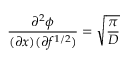<formula> <loc_0><loc_0><loc_500><loc_500>\frac { \partial ^ { 2 } { \phi } } { ( \partial { x } ) ( \partial { f ^ { 1 / 2 } ) } } = \sqrt { \frac { \pi } { D } }</formula> 